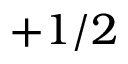Convert formula to latex. <formula><loc_0><loc_0><loc_500><loc_500>+ 1 / 2</formula> 